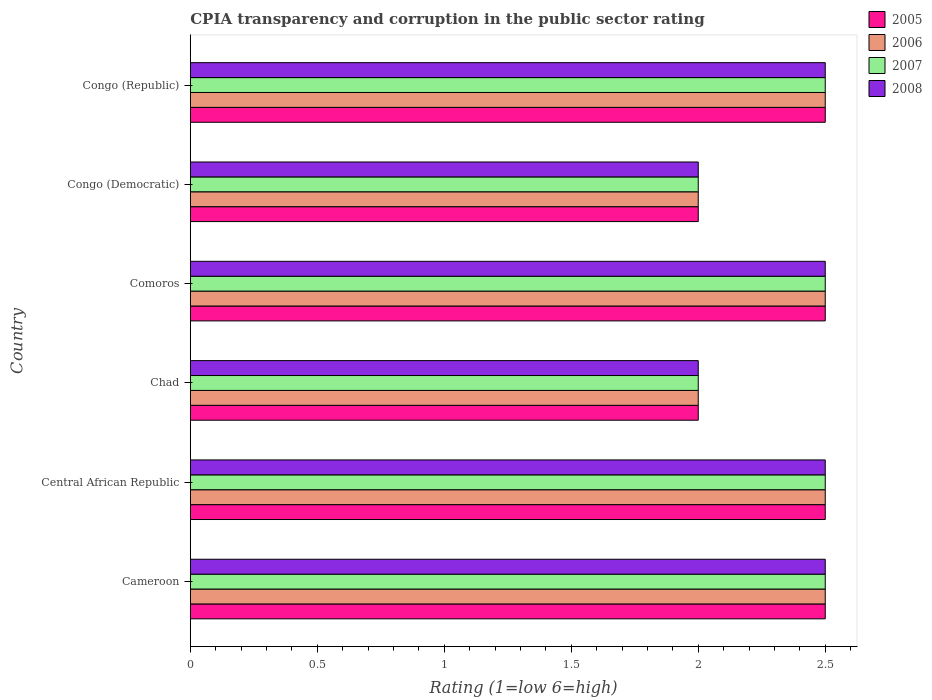How many different coloured bars are there?
Provide a short and direct response. 4. How many bars are there on the 6th tick from the top?
Ensure brevity in your answer.  4. How many bars are there on the 3rd tick from the bottom?
Give a very brief answer. 4. What is the label of the 6th group of bars from the top?
Provide a short and direct response. Cameroon. Across all countries, what is the maximum CPIA rating in 2008?
Your response must be concise. 2.5. Across all countries, what is the minimum CPIA rating in 2007?
Ensure brevity in your answer.  2. In which country was the CPIA rating in 2005 maximum?
Provide a succinct answer. Cameroon. In which country was the CPIA rating in 2006 minimum?
Make the answer very short. Chad. What is the total CPIA rating in 2005 in the graph?
Give a very brief answer. 14. What is the average CPIA rating in 2006 per country?
Offer a terse response. 2.33. Is the CPIA rating in 2008 in Cameroon less than that in Comoros?
Keep it short and to the point. No. What is the difference between the highest and the second highest CPIA rating in 2007?
Your response must be concise. 0. What is the difference between the highest and the lowest CPIA rating in 2007?
Keep it short and to the point. 0.5. What does the 4th bar from the top in Chad represents?
Provide a short and direct response. 2005. What does the 1st bar from the bottom in Congo (Republic) represents?
Keep it short and to the point. 2005. How many bars are there?
Keep it short and to the point. 24. Are all the bars in the graph horizontal?
Provide a succinct answer. Yes. Does the graph contain grids?
Provide a short and direct response. No. Where does the legend appear in the graph?
Your answer should be compact. Top right. What is the title of the graph?
Offer a terse response. CPIA transparency and corruption in the public sector rating. What is the Rating (1=low 6=high) of 2005 in Cameroon?
Offer a very short reply. 2.5. What is the Rating (1=low 6=high) of 2007 in Cameroon?
Offer a terse response. 2.5. What is the Rating (1=low 6=high) of 2008 in Cameroon?
Provide a succinct answer. 2.5. What is the Rating (1=low 6=high) of 2005 in Central African Republic?
Ensure brevity in your answer.  2.5. What is the Rating (1=low 6=high) of 2006 in Central African Republic?
Your answer should be very brief. 2.5. What is the Rating (1=low 6=high) of 2007 in Central African Republic?
Your answer should be very brief. 2.5. What is the Rating (1=low 6=high) of 2008 in Central African Republic?
Provide a succinct answer. 2.5. What is the Rating (1=low 6=high) of 2006 in Chad?
Your answer should be very brief. 2. What is the Rating (1=low 6=high) of 2007 in Chad?
Your answer should be compact. 2. What is the Rating (1=low 6=high) of 2008 in Chad?
Make the answer very short. 2. What is the Rating (1=low 6=high) of 2005 in Comoros?
Your answer should be compact. 2.5. What is the Rating (1=low 6=high) of 2007 in Comoros?
Your response must be concise. 2.5. What is the Rating (1=low 6=high) in 2005 in Congo (Democratic)?
Give a very brief answer. 2. What is the Rating (1=low 6=high) of 2005 in Congo (Republic)?
Your answer should be very brief. 2.5. What is the Rating (1=low 6=high) in 2006 in Congo (Republic)?
Provide a short and direct response. 2.5. What is the Rating (1=low 6=high) in 2007 in Congo (Republic)?
Provide a succinct answer. 2.5. Across all countries, what is the maximum Rating (1=low 6=high) of 2007?
Make the answer very short. 2.5. Across all countries, what is the maximum Rating (1=low 6=high) in 2008?
Your response must be concise. 2.5. Across all countries, what is the minimum Rating (1=low 6=high) in 2005?
Your answer should be very brief. 2. Across all countries, what is the minimum Rating (1=low 6=high) of 2006?
Offer a terse response. 2. What is the total Rating (1=low 6=high) of 2006 in the graph?
Keep it short and to the point. 14. What is the total Rating (1=low 6=high) of 2008 in the graph?
Provide a short and direct response. 14. What is the difference between the Rating (1=low 6=high) in 2005 in Cameroon and that in Central African Republic?
Make the answer very short. 0. What is the difference between the Rating (1=low 6=high) in 2007 in Cameroon and that in Central African Republic?
Make the answer very short. 0. What is the difference between the Rating (1=low 6=high) of 2008 in Cameroon and that in Central African Republic?
Your answer should be very brief. 0. What is the difference between the Rating (1=low 6=high) of 2005 in Cameroon and that in Chad?
Provide a succinct answer. 0.5. What is the difference between the Rating (1=low 6=high) in 2008 in Cameroon and that in Chad?
Make the answer very short. 0.5. What is the difference between the Rating (1=low 6=high) of 2005 in Cameroon and that in Comoros?
Your response must be concise. 0. What is the difference between the Rating (1=low 6=high) in 2007 in Cameroon and that in Comoros?
Offer a very short reply. 0. What is the difference between the Rating (1=low 6=high) of 2008 in Cameroon and that in Comoros?
Your answer should be compact. 0. What is the difference between the Rating (1=low 6=high) in 2006 in Cameroon and that in Congo (Democratic)?
Your response must be concise. 0.5. What is the difference between the Rating (1=low 6=high) of 2008 in Cameroon and that in Congo (Democratic)?
Keep it short and to the point. 0.5. What is the difference between the Rating (1=low 6=high) of 2005 in Cameroon and that in Congo (Republic)?
Offer a very short reply. 0. What is the difference between the Rating (1=low 6=high) in 2007 in Cameroon and that in Congo (Republic)?
Keep it short and to the point. 0. What is the difference between the Rating (1=low 6=high) in 2005 in Central African Republic and that in Chad?
Ensure brevity in your answer.  0.5. What is the difference between the Rating (1=low 6=high) in 2007 in Central African Republic and that in Chad?
Provide a short and direct response. 0.5. What is the difference between the Rating (1=low 6=high) in 2005 in Central African Republic and that in Comoros?
Provide a succinct answer. 0. What is the difference between the Rating (1=low 6=high) in 2006 in Central African Republic and that in Comoros?
Make the answer very short. 0. What is the difference between the Rating (1=low 6=high) of 2006 in Central African Republic and that in Congo (Democratic)?
Offer a terse response. 0.5. What is the difference between the Rating (1=low 6=high) of 2007 in Central African Republic and that in Congo (Democratic)?
Provide a short and direct response. 0.5. What is the difference between the Rating (1=low 6=high) in 2005 in Central African Republic and that in Congo (Republic)?
Your response must be concise. 0. What is the difference between the Rating (1=low 6=high) of 2007 in Central African Republic and that in Congo (Republic)?
Offer a very short reply. 0. What is the difference between the Rating (1=low 6=high) in 2006 in Chad and that in Comoros?
Your response must be concise. -0.5. What is the difference between the Rating (1=low 6=high) of 2007 in Chad and that in Comoros?
Give a very brief answer. -0.5. What is the difference between the Rating (1=low 6=high) of 2008 in Chad and that in Comoros?
Ensure brevity in your answer.  -0.5. What is the difference between the Rating (1=low 6=high) of 2008 in Chad and that in Congo (Democratic)?
Your response must be concise. 0. What is the difference between the Rating (1=low 6=high) in 2005 in Chad and that in Congo (Republic)?
Your response must be concise. -0.5. What is the difference between the Rating (1=low 6=high) of 2006 in Chad and that in Congo (Republic)?
Ensure brevity in your answer.  -0.5. What is the difference between the Rating (1=low 6=high) of 2005 in Comoros and that in Congo (Democratic)?
Make the answer very short. 0.5. What is the difference between the Rating (1=low 6=high) of 2007 in Comoros and that in Congo (Democratic)?
Provide a short and direct response. 0.5. What is the difference between the Rating (1=low 6=high) in 2008 in Comoros and that in Congo (Democratic)?
Your answer should be very brief. 0.5. What is the difference between the Rating (1=low 6=high) of 2006 in Comoros and that in Congo (Republic)?
Your answer should be very brief. 0. What is the difference between the Rating (1=low 6=high) of 2008 in Comoros and that in Congo (Republic)?
Your response must be concise. 0. What is the difference between the Rating (1=low 6=high) in 2005 in Congo (Democratic) and that in Congo (Republic)?
Offer a very short reply. -0.5. What is the difference between the Rating (1=low 6=high) of 2007 in Congo (Democratic) and that in Congo (Republic)?
Provide a short and direct response. -0.5. What is the difference between the Rating (1=low 6=high) in 2005 in Cameroon and the Rating (1=low 6=high) in 2008 in Central African Republic?
Offer a terse response. 0. What is the difference between the Rating (1=low 6=high) of 2006 in Cameroon and the Rating (1=low 6=high) of 2008 in Central African Republic?
Ensure brevity in your answer.  0. What is the difference between the Rating (1=low 6=high) in 2005 in Cameroon and the Rating (1=low 6=high) in 2008 in Chad?
Keep it short and to the point. 0.5. What is the difference between the Rating (1=low 6=high) of 2006 in Cameroon and the Rating (1=low 6=high) of 2007 in Chad?
Offer a terse response. 0.5. What is the difference between the Rating (1=low 6=high) of 2007 in Cameroon and the Rating (1=low 6=high) of 2008 in Chad?
Your answer should be compact. 0.5. What is the difference between the Rating (1=low 6=high) in 2005 in Cameroon and the Rating (1=low 6=high) in 2007 in Comoros?
Keep it short and to the point. 0. What is the difference between the Rating (1=low 6=high) of 2005 in Cameroon and the Rating (1=low 6=high) of 2008 in Comoros?
Keep it short and to the point. 0. What is the difference between the Rating (1=low 6=high) of 2006 in Cameroon and the Rating (1=low 6=high) of 2007 in Comoros?
Ensure brevity in your answer.  0. What is the difference between the Rating (1=low 6=high) of 2007 in Cameroon and the Rating (1=low 6=high) of 2008 in Comoros?
Make the answer very short. 0. What is the difference between the Rating (1=low 6=high) of 2005 in Cameroon and the Rating (1=low 6=high) of 2006 in Congo (Democratic)?
Your answer should be compact. 0.5. What is the difference between the Rating (1=low 6=high) of 2005 in Cameroon and the Rating (1=low 6=high) of 2007 in Congo (Democratic)?
Ensure brevity in your answer.  0.5. What is the difference between the Rating (1=low 6=high) of 2007 in Cameroon and the Rating (1=low 6=high) of 2008 in Congo (Democratic)?
Provide a short and direct response. 0.5. What is the difference between the Rating (1=low 6=high) of 2005 in Cameroon and the Rating (1=low 6=high) of 2006 in Congo (Republic)?
Offer a very short reply. 0. What is the difference between the Rating (1=low 6=high) in 2005 in Cameroon and the Rating (1=low 6=high) in 2007 in Congo (Republic)?
Make the answer very short. 0. What is the difference between the Rating (1=low 6=high) in 2006 in Cameroon and the Rating (1=low 6=high) in 2007 in Congo (Republic)?
Your answer should be compact. 0. What is the difference between the Rating (1=low 6=high) of 2007 in Cameroon and the Rating (1=low 6=high) of 2008 in Congo (Republic)?
Offer a very short reply. 0. What is the difference between the Rating (1=low 6=high) in 2005 in Central African Republic and the Rating (1=low 6=high) in 2007 in Chad?
Ensure brevity in your answer.  0.5. What is the difference between the Rating (1=low 6=high) in 2006 in Central African Republic and the Rating (1=low 6=high) in 2007 in Chad?
Provide a succinct answer. 0.5. What is the difference between the Rating (1=low 6=high) of 2006 in Central African Republic and the Rating (1=low 6=high) of 2008 in Chad?
Offer a very short reply. 0.5. What is the difference between the Rating (1=low 6=high) in 2007 in Central African Republic and the Rating (1=low 6=high) in 2008 in Chad?
Ensure brevity in your answer.  0.5. What is the difference between the Rating (1=low 6=high) in 2005 in Central African Republic and the Rating (1=low 6=high) in 2006 in Comoros?
Your answer should be compact. 0. What is the difference between the Rating (1=low 6=high) of 2005 in Central African Republic and the Rating (1=low 6=high) of 2007 in Comoros?
Your response must be concise. 0. What is the difference between the Rating (1=low 6=high) of 2006 in Central African Republic and the Rating (1=low 6=high) of 2008 in Comoros?
Your response must be concise. 0. What is the difference between the Rating (1=low 6=high) in 2005 in Central African Republic and the Rating (1=low 6=high) in 2006 in Congo (Democratic)?
Ensure brevity in your answer.  0.5. What is the difference between the Rating (1=low 6=high) in 2005 in Central African Republic and the Rating (1=low 6=high) in 2007 in Congo (Democratic)?
Your answer should be very brief. 0.5. What is the difference between the Rating (1=low 6=high) in 2005 in Central African Republic and the Rating (1=low 6=high) in 2008 in Congo (Democratic)?
Offer a terse response. 0.5. What is the difference between the Rating (1=low 6=high) in 2005 in Central African Republic and the Rating (1=low 6=high) in 2007 in Congo (Republic)?
Provide a short and direct response. 0. What is the difference between the Rating (1=low 6=high) in 2005 in Central African Republic and the Rating (1=low 6=high) in 2008 in Congo (Republic)?
Your response must be concise. 0. What is the difference between the Rating (1=low 6=high) of 2006 in Central African Republic and the Rating (1=low 6=high) of 2007 in Congo (Republic)?
Your response must be concise. 0. What is the difference between the Rating (1=low 6=high) in 2006 in Central African Republic and the Rating (1=low 6=high) in 2008 in Congo (Republic)?
Provide a short and direct response. 0. What is the difference between the Rating (1=low 6=high) of 2007 in Central African Republic and the Rating (1=low 6=high) of 2008 in Congo (Republic)?
Your answer should be very brief. 0. What is the difference between the Rating (1=low 6=high) in 2005 in Chad and the Rating (1=low 6=high) in 2006 in Comoros?
Keep it short and to the point. -0.5. What is the difference between the Rating (1=low 6=high) of 2005 in Chad and the Rating (1=low 6=high) of 2007 in Comoros?
Your answer should be compact. -0.5. What is the difference between the Rating (1=low 6=high) of 2005 in Chad and the Rating (1=low 6=high) of 2008 in Comoros?
Provide a succinct answer. -0.5. What is the difference between the Rating (1=low 6=high) of 2006 in Chad and the Rating (1=low 6=high) of 2008 in Comoros?
Offer a terse response. -0.5. What is the difference between the Rating (1=low 6=high) in 2005 in Chad and the Rating (1=low 6=high) in 2006 in Congo (Democratic)?
Provide a succinct answer. 0. What is the difference between the Rating (1=low 6=high) of 2005 in Chad and the Rating (1=low 6=high) of 2007 in Congo (Democratic)?
Your response must be concise. 0. What is the difference between the Rating (1=low 6=high) in 2005 in Chad and the Rating (1=low 6=high) in 2008 in Congo (Democratic)?
Your answer should be very brief. 0. What is the difference between the Rating (1=low 6=high) in 2006 in Chad and the Rating (1=low 6=high) in 2008 in Congo (Democratic)?
Provide a short and direct response. 0. What is the difference between the Rating (1=low 6=high) of 2005 in Chad and the Rating (1=low 6=high) of 2006 in Congo (Republic)?
Your answer should be very brief. -0.5. What is the difference between the Rating (1=low 6=high) of 2005 in Chad and the Rating (1=low 6=high) of 2007 in Congo (Republic)?
Keep it short and to the point. -0.5. What is the difference between the Rating (1=low 6=high) in 2005 in Chad and the Rating (1=low 6=high) in 2008 in Congo (Republic)?
Offer a very short reply. -0.5. What is the difference between the Rating (1=low 6=high) of 2006 in Chad and the Rating (1=low 6=high) of 2008 in Congo (Republic)?
Provide a succinct answer. -0.5. What is the difference between the Rating (1=low 6=high) of 2007 in Chad and the Rating (1=low 6=high) of 2008 in Congo (Republic)?
Keep it short and to the point. -0.5. What is the difference between the Rating (1=low 6=high) in 2005 in Comoros and the Rating (1=low 6=high) in 2006 in Congo (Democratic)?
Ensure brevity in your answer.  0.5. What is the difference between the Rating (1=low 6=high) of 2006 in Comoros and the Rating (1=low 6=high) of 2007 in Congo (Democratic)?
Your answer should be very brief. 0.5. What is the difference between the Rating (1=low 6=high) in 2005 in Comoros and the Rating (1=low 6=high) in 2007 in Congo (Republic)?
Keep it short and to the point. 0. What is the difference between the Rating (1=low 6=high) in 2005 in Congo (Democratic) and the Rating (1=low 6=high) in 2006 in Congo (Republic)?
Offer a very short reply. -0.5. What is the difference between the Rating (1=low 6=high) in 2005 in Congo (Democratic) and the Rating (1=low 6=high) in 2007 in Congo (Republic)?
Offer a very short reply. -0.5. What is the difference between the Rating (1=low 6=high) in 2005 in Congo (Democratic) and the Rating (1=low 6=high) in 2008 in Congo (Republic)?
Keep it short and to the point. -0.5. What is the difference between the Rating (1=low 6=high) in 2007 in Congo (Democratic) and the Rating (1=low 6=high) in 2008 in Congo (Republic)?
Your response must be concise. -0.5. What is the average Rating (1=low 6=high) in 2005 per country?
Your answer should be very brief. 2.33. What is the average Rating (1=low 6=high) in 2006 per country?
Ensure brevity in your answer.  2.33. What is the average Rating (1=low 6=high) in 2007 per country?
Give a very brief answer. 2.33. What is the average Rating (1=low 6=high) in 2008 per country?
Ensure brevity in your answer.  2.33. What is the difference between the Rating (1=low 6=high) of 2005 and Rating (1=low 6=high) of 2006 in Cameroon?
Offer a terse response. 0. What is the difference between the Rating (1=low 6=high) of 2006 and Rating (1=low 6=high) of 2007 in Central African Republic?
Offer a very short reply. 0. What is the difference between the Rating (1=low 6=high) of 2006 and Rating (1=low 6=high) of 2008 in Central African Republic?
Keep it short and to the point. 0. What is the difference between the Rating (1=low 6=high) in 2005 and Rating (1=low 6=high) in 2006 in Chad?
Provide a succinct answer. 0. What is the difference between the Rating (1=low 6=high) in 2005 and Rating (1=low 6=high) in 2007 in Chad?
Your answer should be compact. 0. What is the difference between the Rating (1=low 6=high) of 2006 and Rating (1=low 6=high) of 2007 in Chad?
Give a very brief answer. 0. What is the difference between the Rating (1=low 6=high) of 2005 and Rating (1=low 6=high) of 2007 in Comoros?
Your answer should be compact. 0. What is the difference between the Rating (1=low 6=high) in 2006 and Rating (1=low 6=high) in 2008 in Comoros?
Ensure brevity in your answer.  0. What is the difference between the Rating (1=low 6=high) in 2006 and Rating (1=low 6=high) in 2008 in Congo (Democratic)?
Provide a short and direct response. 0. What is the difference between the Rating (1=low 6=high) in 2007 and Rating (1=low 6=high) in 2008 in Congo (Democratic)?
Give a very brief answer. 0. What is the difference between the Rating (1=low 6=high) of 2005 and Rating (1=low 6=high) of 2008 in Congo (Republic)?
Make the answer very short. 0. What is the difference between the Rating (1=low 6=high) of 2006 and Rating (1=low 6=high) of 2007 in Congo (Republic)?
Your response must be concise. 0. What is the difference between the Rating (1=low 6=high) in 2006 and Rating (1=low 6=high) in 2008 in Congo (Republic)?
Your answer should be very brief. 0. What is the ratio of the Rating (1=low 6=high) in 2007 in Cameroon to that in Central African Republic?
Your answer should be very brief. 1. What is the ratio of the Rating (1=low 6=high) of 2008 in Cameroon to that in Central African Republic?
Keep it short and to the point. 1. What is the ratio of the Rating (1=low 6=high) of 2005 in Cameroon to that in Chad?
Your response must be concise. 1.25. What is the ratio of the Rating (1=low 6=high) in 2007 in Cameroon to that in Comoros?
Your response must be concise. 1. What is the ratio of the Rating (1=low 6=high) in 2006 in Cameroon to that in Congo (Democratic)?
Your answer should be compact. 1.25. What is the ratio of the Rating (1=low 6=high) of 2007 in Cameroon to that in Congo (Democratic)?
Make the answer very short. 1.25. What is the ratio of the Rating (1=low 6=high) of 2008 in Cameroon to that in Congo (Democratic)?
Ensure brevity in your answer.  1.25. What is the ratio of the Rating (1=low 6=high) of 2005 in Cameroon to that in Congo (Republic)?
Ensure brevity in your answer.  1. What is the ratio of the Rating (1=low 6=high) of 2006 in Cameroon to that in Congo (Republic)?
Give a very brief answer. 1. What is the ratio of the Rating (1=low 6=high) of 2008 in Cameroon to that in Congo (Republic)?
Your answer should be compact. 1. What is the ratio of the Rating (1=low 6=high) in 2006 in Central African Republic to that in Chad?
Your answer should be compact. 1.25. What is the ratio of the Rating (1=low 6=high) of 2005 in Central African Republic to that in Comoros?
Give a very brief answer. 1. What is the ratio of the Rating (1=low 6=high) in 2006 in Central African Republic to that in Comoros?
Offer a very short reply. 1. What is the ratio of the Rating (1=low 6=high) of 2007 in Central African Republic to that in Comoros?
Provide a short and direct response. 1. What is the ratio of the Rating (1=low 6=high) in 2008 in Central African Republic to that in Comoros?
Provide a succinct answer. 1. What is the ratio of the Rating (1=low 6=high) in 2005 in Central African Republic to that in Congo (Democratic)?
Provide a succinct answer. 1.25. What is the ratio of the Rating (1=low 6=high) of 2007 in Central African Republic to that in Congo (Democratic)?
Provide a succinct answer. 1.25. What is the ratio of the Rating (1=low 6=high) of 2008 in Central African Republic to that in Congo (Democratic)?
Provide a succinct answer. 1.25. What is the ratio of the Rating (1=low 6=high) of 2008 in Central African Republic to that in Congo (Republic)?
Give a very brief answer. 1. What is the ratio of the Rating (1=low 6=high) in 2006 in Chad to that in Comoros?
Give a very brief answer. 0.8. What is the ratio of the Rating (1=low 6=high) of 2007 in Chad to that in Comoros?
Make the answer very short. 0.8. What is the ratio of the Rating (1=low 6=high) of 2008 in Chad to that in Comoros?
Offer a very short reply. 0.8. What is the ratio of the Rating (1=low 6=high) in 2006 in Chad to that in Congo (Democratic)?
Offer a terse response. 1. What is the ratio of the Rating (1=low 6=high) of 2008 in Chad to that in Congo (Democratic)?
Offer a very short reply. 1. What is the ratio of the Rating (1=low 6=high) of 2007 in Chad to that in Congo (Republic)?
Make the answer very short. 0.8. What is the ratio of the Rating (1=low 6=high) in 2006 in Comoros to that in Congo (Democratic)?
Your response must be concise. 1.25. What is the ratio of the Rating (1=low 6=high) in 2006 in Comoros to that in Congo (Republic)?
Your answer should be compact. 1. What is the ratio of the Rating (1=low 6=high) in 2006 in Congo (Democratic) to that in Congo (Republic)?
Your answer should be very brief. 0.8. What is the ratio of the Rating (1=low 6=high) in 2007 in Congo (Democratic) to that in Congo (Republic)?
Make the answer very short. 0.8. What is the difference between the highest and the second highest Rating (1=low 6=high) in 2005?
Your response must be concise. 0. What is the difference between the highest and the lowest Rating (1=low 6=high) of 2005?
Provide a short and direct response. 0.5. What is the difference between the highest and the lowest Rating (1=low 6=high) in 2006?
Ensure brevity in your answer.  0.5. What is the difference between the highest and the lowest Rating (1=low 6=high) of 2007?
Provide a succinct answer. 0.5. What is the difference between the highest and the lowest Rating (1=low 6=high) of 2008?
Ensure brevity in your answer.  0.5. 